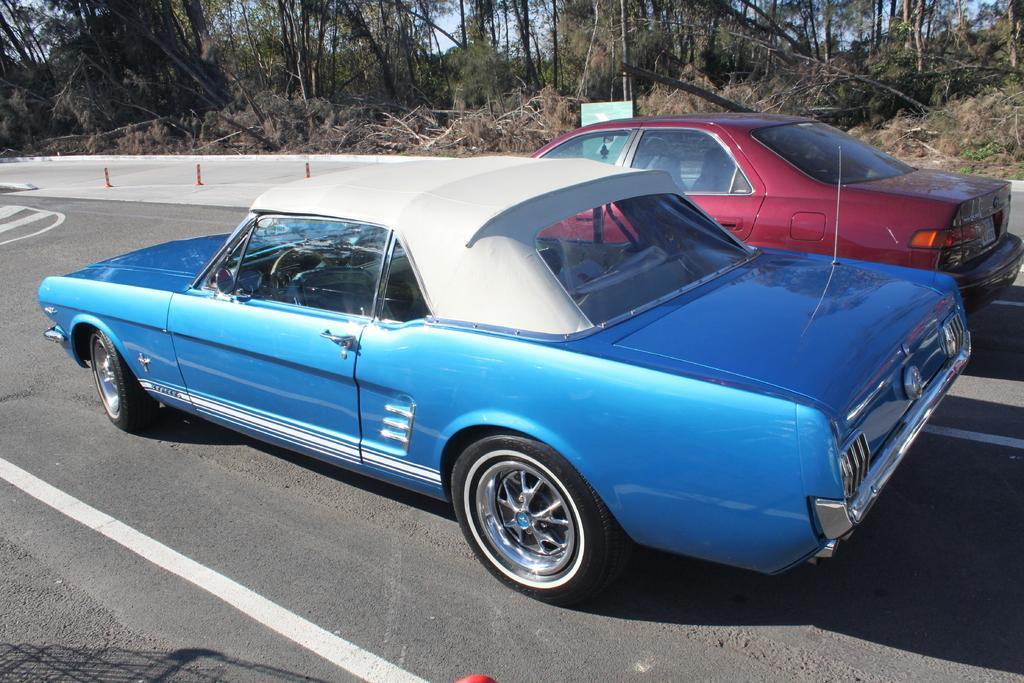Describe this image in one or two sentences. In this picture we can see two cars on the road, poles, trees and some objects and in the background we can see the sky. 